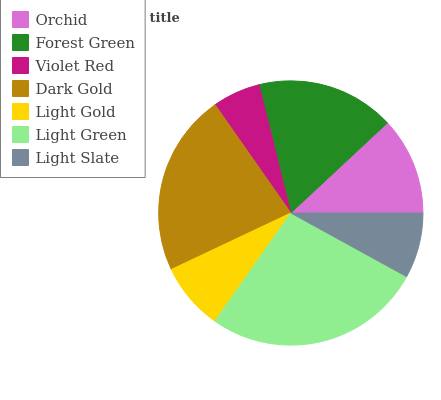Is Violet Red the minimum?
Answer yes or no. Yes. Is Light Green the maximum?
Answer yes or no. Yes. Is Forest Green the minimum?
Answer yes or no. No. Is Forest Green the maximum?
Answer yes or no. No. Is Forest Green greater than Orchid?
Answer yes or no. Yes. Is Orchid less than Forest Green?
Answer yes or no. Yes. Is Orchid greater than Forest Green?
Answer yes or no. No. Is Forest Green less than Orchid?
Answer yes or no. No. Is Orchid the high median?
Answer yes or no. Yes. Is Orchid the low median?
Answer yes or no. Yes. Is Violet Red the high median?
Answer yes or no. No. Is Dark Gold the low median?
Answer yes or no. No. 